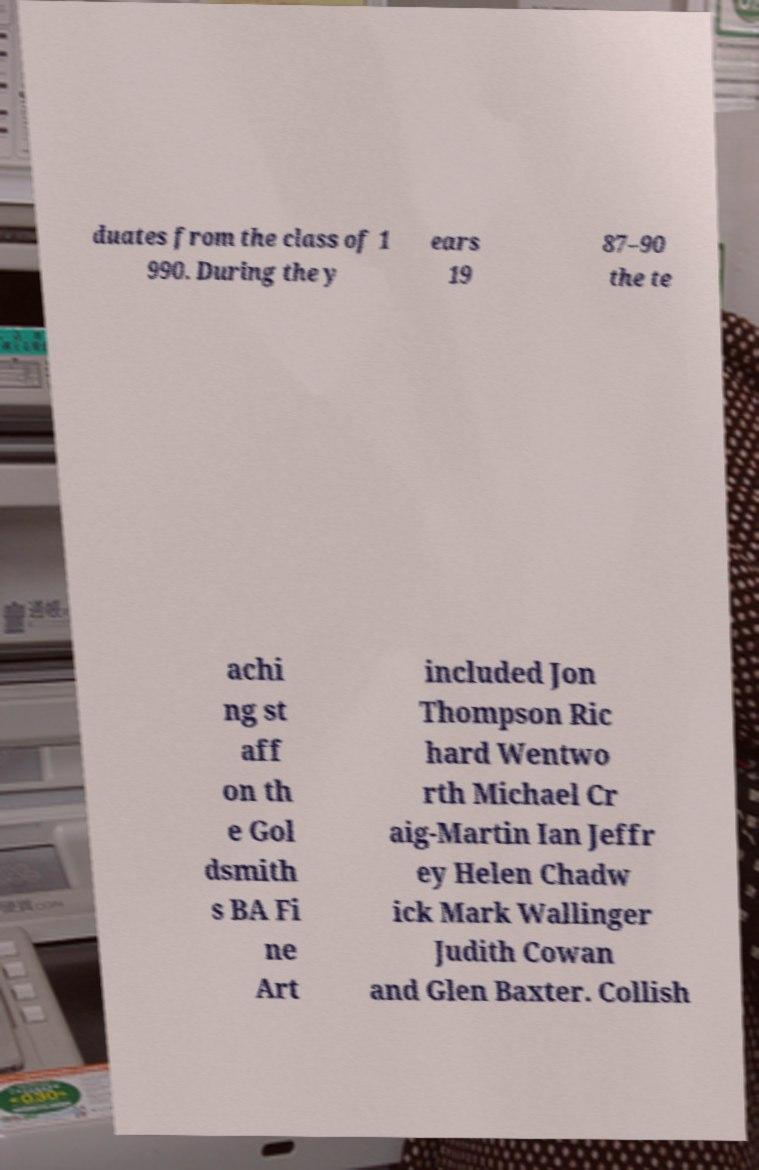Can you accurately transcribe the text from the provided image for me? duates from the class of 1 990. During the y ears 19 87–90 the te achi ng st aff on th e Gol dsmith s BA Fi ne Art included Jon Thompson Ric hard Wentwo rth Michael Cr aig-Martin Ian Jeffr ey Helen Chadw ick Mark Wallinger Judith Cowan and Glen Baxter. Collish 